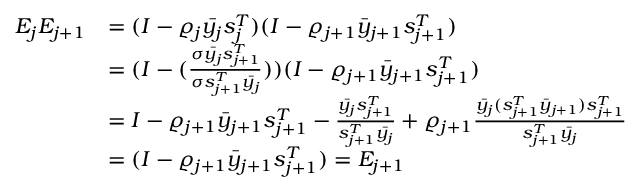<formula> <loc_0><loc_0><loc_500><loc_500>\begin{array} { r l } { E _ { j } E _ { j + 1 } } & { = ( I - \varrho _ { j } \bar { y _ { j } } s _ { j } ^ { T } ) ( I - \varrho _ { j + 1 } \bar { y } _ { j + 1 } s _ { j + 1 } ^ { T } ) } \\ & { = ( I - ( \frac { \sigma \bar { y _ { j } } s _ { j + 1 } ^ { T } } { \sigma s _ { j + 1 } ^ { T } \bar { y _ { j } } } ) ) ( I - \varrho _ { j + 1 } \bar { y } _ { j + 1 } s _ { j + 1 } ^ { T } ) } \\ & { = I - \varrho _ { j + 1 } \bar { y } _ { j + 1 } s _ { j + 1 } ^ { T } - \frac { \bar { y _ { j } } s _ { j + 1 } ^ { T } } { s _ { j + 1 } ^ { T } \bar { y _ { j } } } + \varrho _ { j + 1 } \frac { \bar { y _ { j } } ( s _ { j + 1 } ^ { T } \bar { y } _ { j + 1 } ) s _ { j + 1 } ^ { T } } { s _ { j + 1 } ^ { T } \bar { y _ { j } } } } \\ & { = ( I - \varrho _ { j + 1 } \bar { y } _ { j + 1 } s _ { j + 1 } ^ { T } ) = E _ { j + 1 } } \end{array}</formula> 